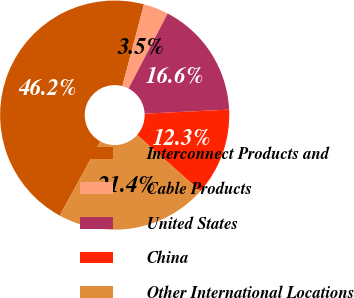Convert chart. <chart><loc_0><loc_0><loc_500><loc_500><pie_chart><fcel>Interconnect Products and<fcel>Cable Products<fcel>United States<fcel>China<fcel>Other International Locations<nl><fcel>46.16%<fcel>3.53%<fcel>16.59%<fcel>12.33%<fcel>21.39%<nl></chart> 